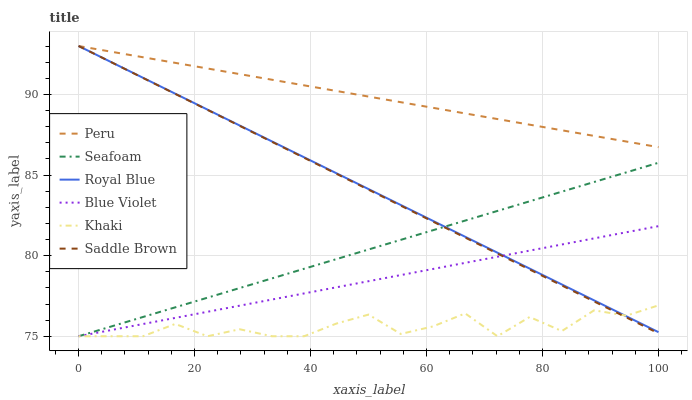Does Seafoam have the minimum area under the curve?
Answer yes or no. No. Does Seafoam have the maximum area under the curve?
Answer yes or no. No. Is Seafoam the smoothest?
Answer yes or no. No. Is Seafoam the roughest?
Answer yes or no. No. Does Royal Blue have the lowest value?
Answer yes or no. No. Does Seafoam have the highest value?
Answer yes or no. No. Is Seafoam less than Peru?
Answer yes or no. Yes. Is Peru greater than Seafoam?
Answer yes or no. Yes. Does Seafoam intersect Peru?
Answer yes or no. No. 